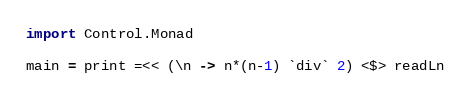Convert code to text. <code><loc_0><loc_0><loc_500><loc_500><_Haskell_>import Control.Monad

main = print =<< (\n -> n*(n-1) `div` 2) <$> readLn</code> 